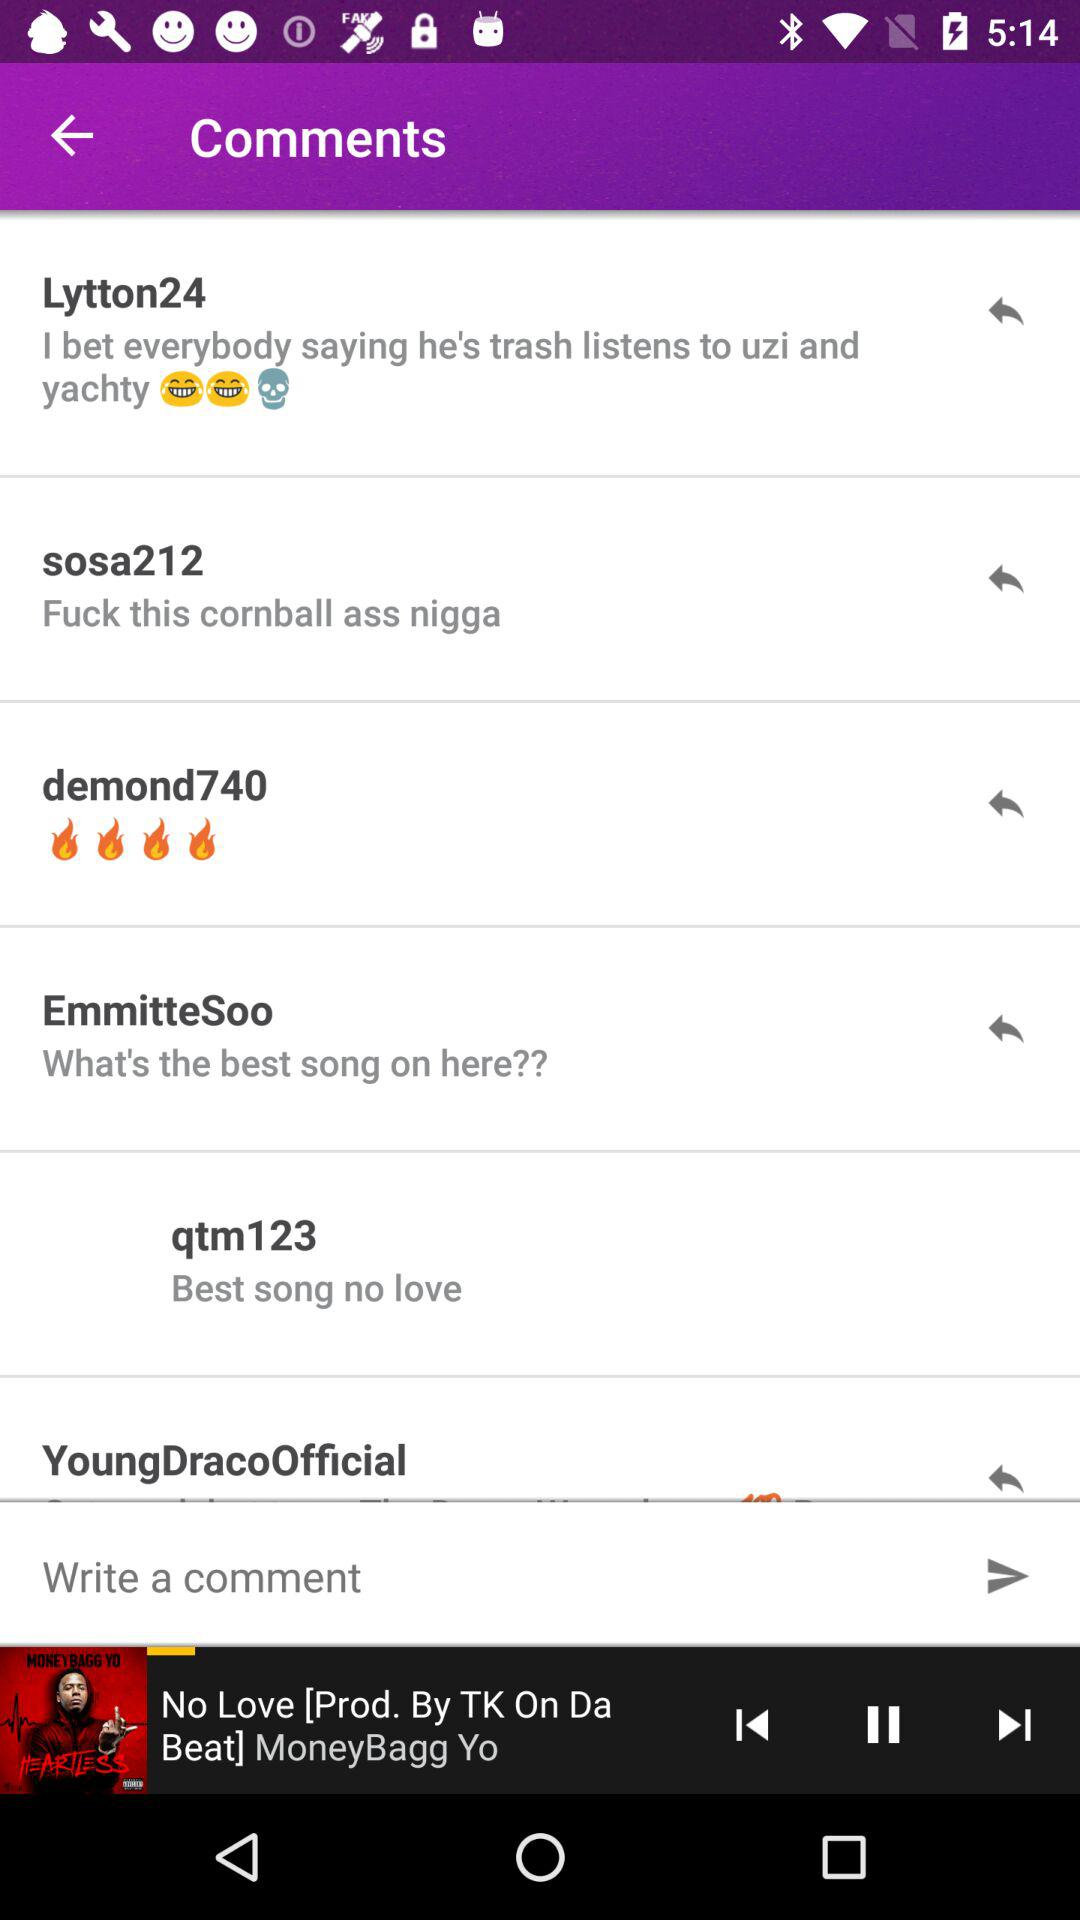What is the name of the song that is playing? The name of the song is "No Love [Prod. By TK On Da Beat]". 